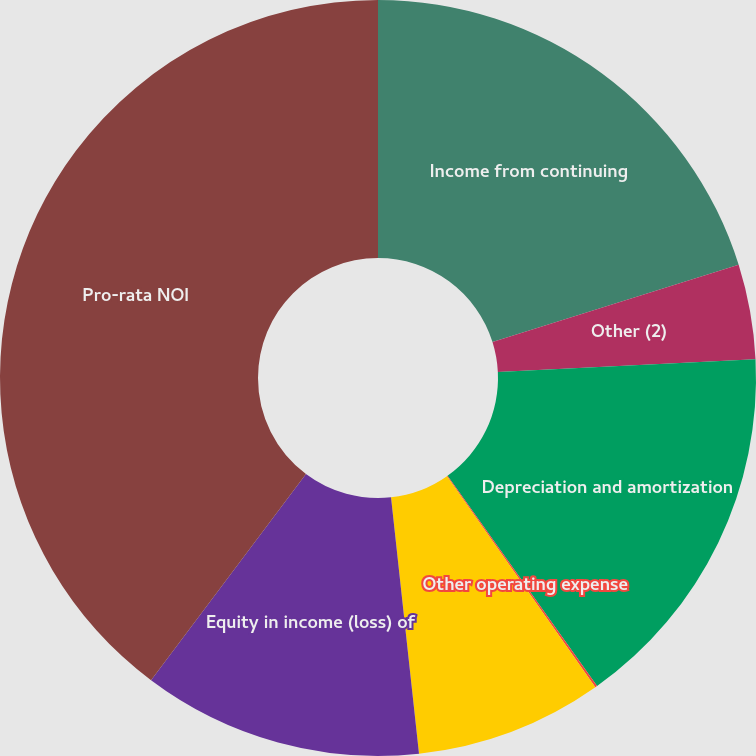Convert chart to OTSL. <chart><loc_0><loc_0><loc_500><loc_500><pie_chart><fcel>Income from continuing<fcel>Other (2)<fcel>Depreciation and amortization<fcel>Other operating expense<fcel>Other expense (income)<fcel>Equity in income (loss) of<fcel>Pro-rata NOI<nl><fcel>20.16%<fcel>4.05%<fcel>15.95%<fcel>0.09%<fcel>8.02%<fcel>11.98%<fcel>39.75%<nl></chart> 